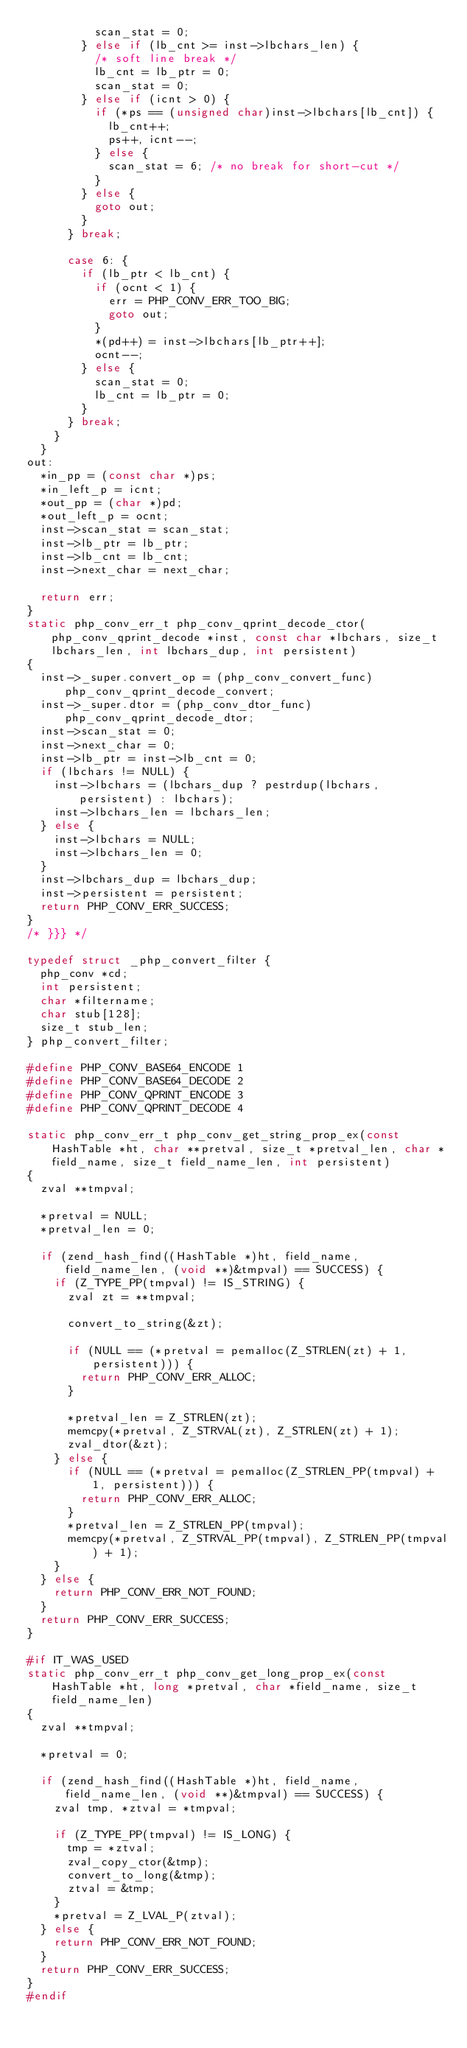<code> <loc_0><loc_0><loc_500><loc_500><_C_>					scan_stat = 0;
				} else if (lb_cnt >= inst->lbchars_len) {
					/* soft line break */
					lb_cnt = lb_ptr = 0;
					scan_stat = 0;
				} else if (icnt > 0) {
					if (*ps == (unsigned char)inst->lbchars[lb_cnt]) {
						lb_cnt++;
						ps++, icnt--;
					} else {
						scan_stat = 6; /* no break for short-cut */
					}
				} else {
					goto out;
				}
			} break;

			case 6: {
				if (lb_ptr < lb_cnt) {
					if (ocnt < 1) {
						err = PHP_CONV_ERR_TOO_BIG;
						goto out;
					}
					*(pd++) = inst->lbchars[lb_ptr++];
					ocnt--;
				} else {
					scan_stat = 0;
					lb_cnt = lb_ptr = 0;
				}
			} break;
		}
	}
out:
	*in_pp = (const char *)ps;
	*in_left_p = icnt;
	*out_pp = (char *)pd;
	*out_left_p = ocnt;
	inst->scan_stat = scan_stat;
	inst->lb_ptr = lb_ptr;
	inst->lb_cnt = lb_cnt;
	inst->next_char = next_char;

	return err;
}
static php_conv_err_t php_conv_qprint_decode_ctor(php_conv_qprint_decode *inst, const char *lbchars, size_t lbchars_len, int lbchars_dup, int persistent)
{
	inst->_super.convert_op = (php_conv_convert_func) php_conv_qprint_decode_convert;
	inst->_super.dtor = (php_conv_dtor_func) php_conv_qprint_decode_dtor;
	inst->scan_stat = 0;
	inst->next_char = 0;
	inst->lb_ptr = inst->lb_cnt = 0;
	if (lbchars != NULL) {
		inst->lbchars = (lbchars_dup ? pestrdup(lbchars, persistent) : lbchars);
		inst->lbchars_len = lbchars_len;
	} else {
		inst->lbchars = NULL;
		inst->lbchars_len = 0;
	}
	inst->lbchars_dup = lbchars_dup;
	inst->persistent = persistent;
	return PHP_CONV_ERR_SUCCESS;
}
/* }}} */

typedef struct _php_convert_filter {
	php_conv *cd;
	int persistent;
	char *filtername;
	char stub[128];
	size_t stub_len;
} php_convert_filter;

#define PHP_CONV_BASE64_ENCODE 1
#define PHP_CONV_BASE64_DECODE 2
#define PHP_CONV_QPRINT_ENCODE 3 
#define PHP_CONV_QPRINT_DECODE 4

static php_conv_err_t php_conv_get_string_prop_ex(const HashTable *ht, char **pretval, size_t *pretval_len, char *field_name, size_t field_name_len, int persistent)
{
	zval **tmpval;

	*pretval = NULL;
	*pretval_len = 0;
 
	if (zend_hash_find((HashTable *)ht, field_name, field_name_len, (void **)&tmpval) == SUCCESS) {
		if (Z_TYPE_PP(tmpval) != IS_STRING) {
			zval zt = **tmpval;

			convert_to_string(&zt);

			if (NULL == (*pretval = pemalloc(Z_STRLEN(zt) + 1, persistent))) {
				return PHP_CONV_ERR_ALLOC;
			}

			*pretval_len = Z_STRLEN(zt);
			memcpy(*pretval, Z_STRVAL(zt), Z_STRLEN(zt) + 1);
			zval_dtor(&zt);
		} else {
			if (NULL == (*pretval = pemalloc(Z_STRLEN_PP(tmpval) + 1, persistent))) {
				return PHP_CONV_ERR_ALLOC;
			}
			*pretval_len = Z_STRLEN_PP(tmpval);
			memcpy(*pretval, Z_STRVAL_PP(tmpval), Z_STRLEN_PP(tmpval) + 1);
		}
	} else {
		return PHP_CONV_ERR_NOT_FOUND;
	}
	return PHP_CONV_ERR_SUCCESS;
}

#if IT_WAS_USED
static php_conv_err_t php_conv_get_long_prop_ex(const HashTable *ht, long *pretval, char *field_name, size_t field_name_len)
{
	zval **tmpval;

	*pretval = 0;

	if (zend_hash_find((HashTable *)ht, field_name, field_name_len, (void **)&tmpval) == SUCCESS) {
		zval tmp, *ztval = *tmpval;

		if (Z_TYPE_PP(tmpval) != IS_LONG) {
			tmp = *ztval;
			zval_copy_ctor(&tmp);
			convert_to_long(&tmp);
			ztval = &tmp;
		}
		*pretval = Z_LVAL_P(ztval);
	} else {
		return PHP_CONV_ERR_NOT_FOUND;
	} 
	return PHP_CONV_ERR_SUCCESS;
}
#endif
</code> 